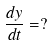<formula> <loc_0><loc_0><loc_500><loc_500>\frac { d y } { d t } = ?</formula> 